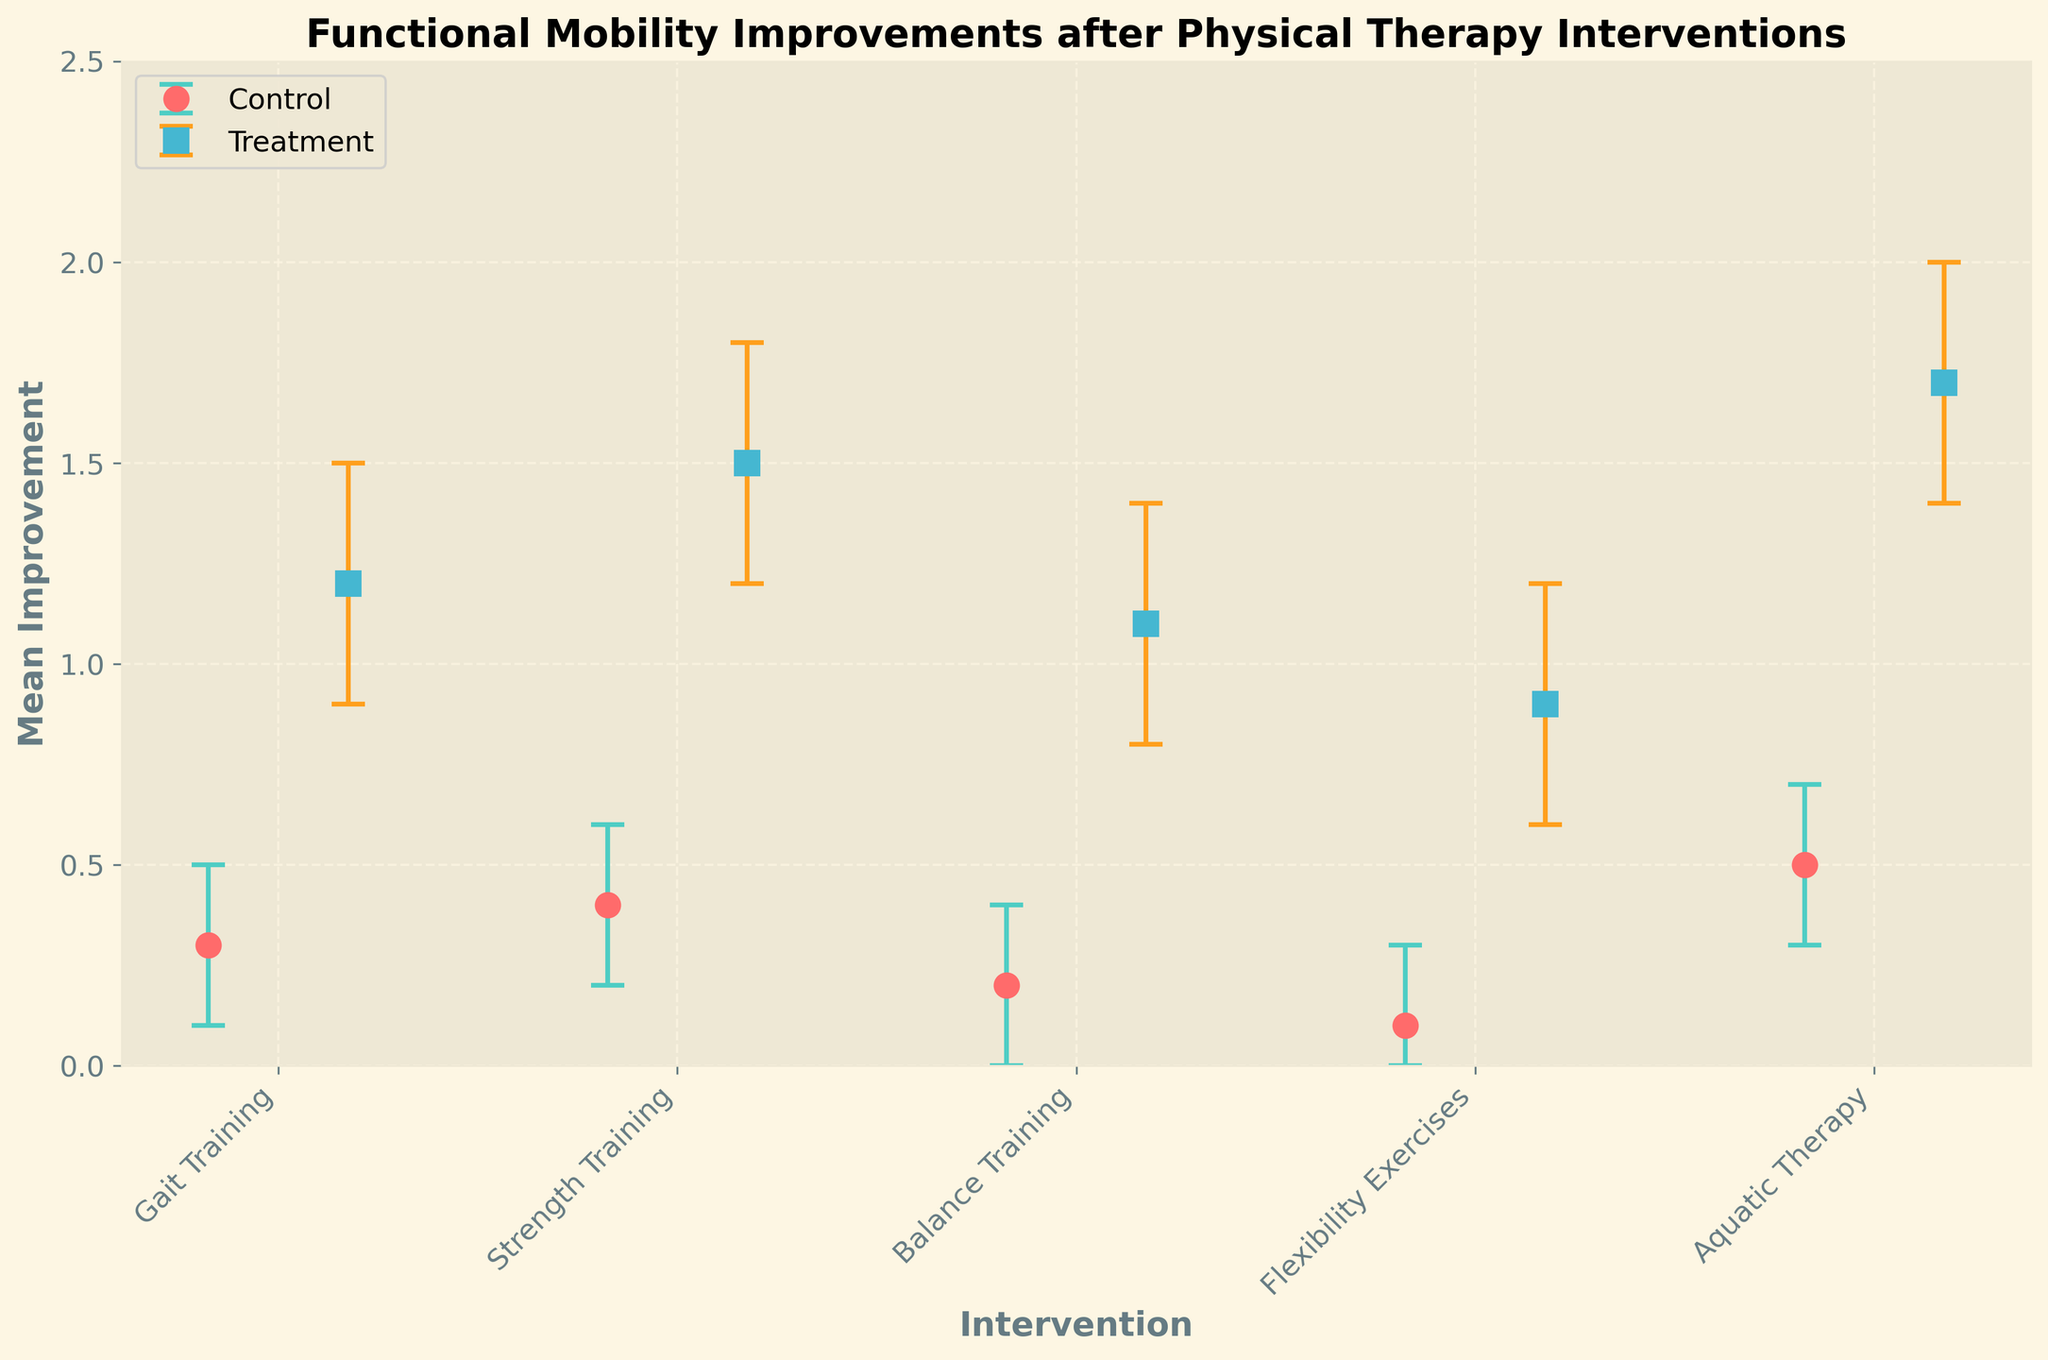What is the title of the plot? The title of the plot is usually displayed at the top and summarizes what the figure is about. In this case, it indicates the main subject.
Answer: Functional Mobility Improvements after Physical Therapy Interventions What is the mean improvement for the Treatment group in Balance Training? Locate the dot corresponding to the Treatment group for Balance Training and read the mean improvement value from the plot.
Answer: 1.1 Which intervention had the highest mean improvement in the Treatment group? Observe all the data points that represent the Treatment group and identify the one with the maximum y-value.
Answer: Aquatic Therapy How many types of interventions are plotted in the figure? Count the number of unique interventions listed on the x-axis.
Answer: 5 What is the general trend observed when comparing Treatment and Control groups? Examine each pair of data points for each intervention to see if there's a consistent relationship in improvements between the Treatment and Control groups.
Answer: Treatment usually shows higher improvements than Control What are the lower and upper confidence intervals for the Control group in Strength Training? Check the error bars for the relevant data point and read the lower and upper confidence interval values.
Answer: 0.2 and 0.6 Which intervention shows the smallest improvement for the Control group? Compare all the mean improvement values for different interventions in the Control group and pick the smallest one.
Answer: Flexibility Exercises How much greater is the mean improvement in the Treatment group compared to the Control group for Gait Training? Find the mean improvements for both groups, then subtract Control from Treatment to determine the difference.
Answer: 0.9 Which intervention has the smallest range of confidence intervals in the Treatment group? Calculate the range of confidence intervals for each intervention in the Treatment group, then find the smallest range.
Answer: Balance Training Is there any intervention where the Control group's mean improvement exceeds 0.5? Check the mean improvement values for the Control group across all interventions and see if any are greater than 0.5.
Answer: No 